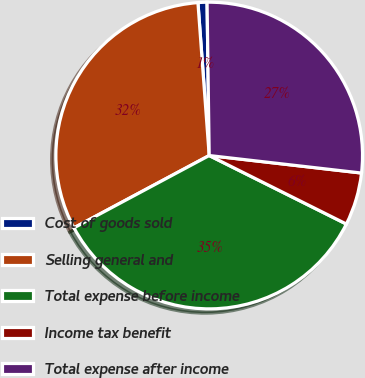<chart> <loc_0><loc_0><loc_500><loc_500><pie_chart><fcel>Cost of goods sold<fcel>Selling general and<fcel>Total expense before income<fcel>Income tax benefit<fcel>Total expense after income<nl><fcel>0.95%<fcel>31.64%<fcel>34.81%<fcel>5.55%<fcel>27.04%<nl></chart> 